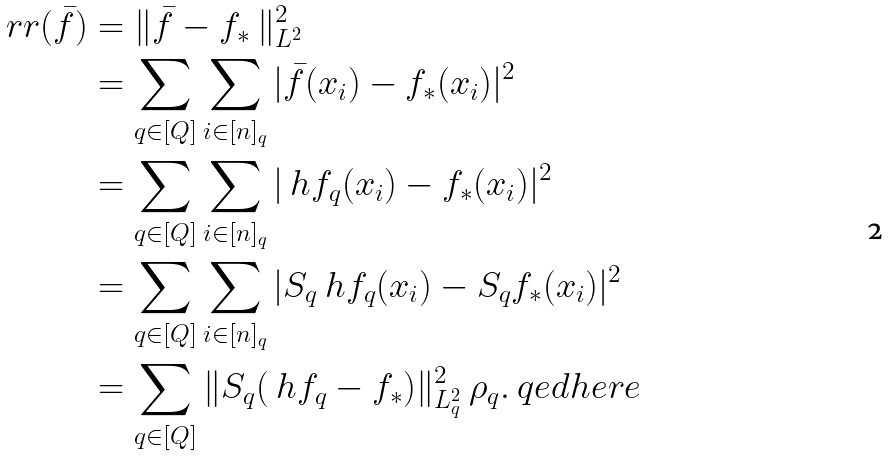<formula> <loc_0><loc_0><loc_500><loc_500>\ r r ( \bar { f } ) & = \| \bar { f } - f _ { * } \ \| _ { L ^ { 2 } } ^ { 2 } \\ & = \sum _ { q \in [ Q ] } \sum _ { i \in [ n ] _ { q } } | \bar { f } ( x _ { i } ) - f _ { * } ( x _ { i } ) | ^ { 2 } \\ & = \sum _ { q \in [ Q ] } \sum _ { i \in [ n ] _ { q } } | \ h { f } _ { q } ( x _ { i } ) - f _ { * } ( x _ { i } ) | ^ { 2 } \\ & = \sum _ { q \in [ Q ] } \sum _ { i \in [ n ] _ { q } } | S _ { q } \ h { f } _ { q } ( x _ { i } ) - S _ { q } f _ { * } ( x _ { i } ) | ^ { 2 } \\ & = \sum _ { q \in [ Q ] } \| S _ { q } ( \ h { f } _ { q } - f _ { * } ) \| _ { L ^ { 2 } _ { q } } ^ { 2 } \ \rho _ { q } . \ q e d h e r e</formula> 